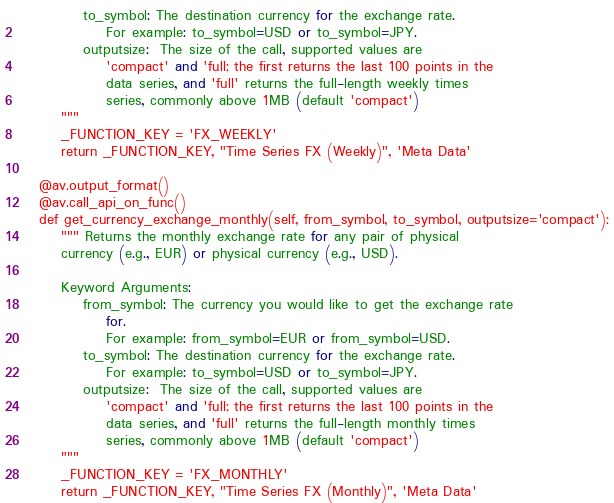Convert code to text. <code><loc_0><loc_0><loc_500><loc_500><_Python_>            to_symbol: The destination currency for the exchange rate.
                For example: to_symbol=USD or to_symbol=JPY.
            outputsize:  The size of the call, supported values are
                'compact' and 'full; the first returns the last 100 points in the
                data series, and 'full' returns the full-length weekly times
                series, commonly above 1MB (default 'compact')
        """
        _FUNCTION_KEY = 'FX_WEEKLY'
        return _FUNCTION_KEY, "Time Series FX (Weekly)", 'Meta Data'

    @av.output_format()
    @av.call_api_on_func()
    def get_currency_exchange_monthly(self, from_symbol, to_symbol, outputsize='compact'):
        """ Returns the monthly exchange rate for any pair of physical
        currency (e.g., EUR) or physical currency (e.g., USD).

        Keyword Arguments:
            from_symbol: The currency you would like to get the exchange rate
                for.
                For example: from_symbol=EUR or from_symbol=USD.
            to_symbol: The destination currency for the exchange rate.
                For example: to_symbol=USD or to_symbol=JPY.
            outputsize:  The size of the call, supported values are
                'compact' and 'full; the first returns the last 100 points in the
                data series, and 'full' returns the full-length monthly times
                series, commonly above 1MB (default 'compact')
        """
        _FUNCTION_KEY = 'FX_MONTHLY'
        return _FUNCTION_KEY, "Time Series FX (Monthly)", 'Meta Data'
</code> 